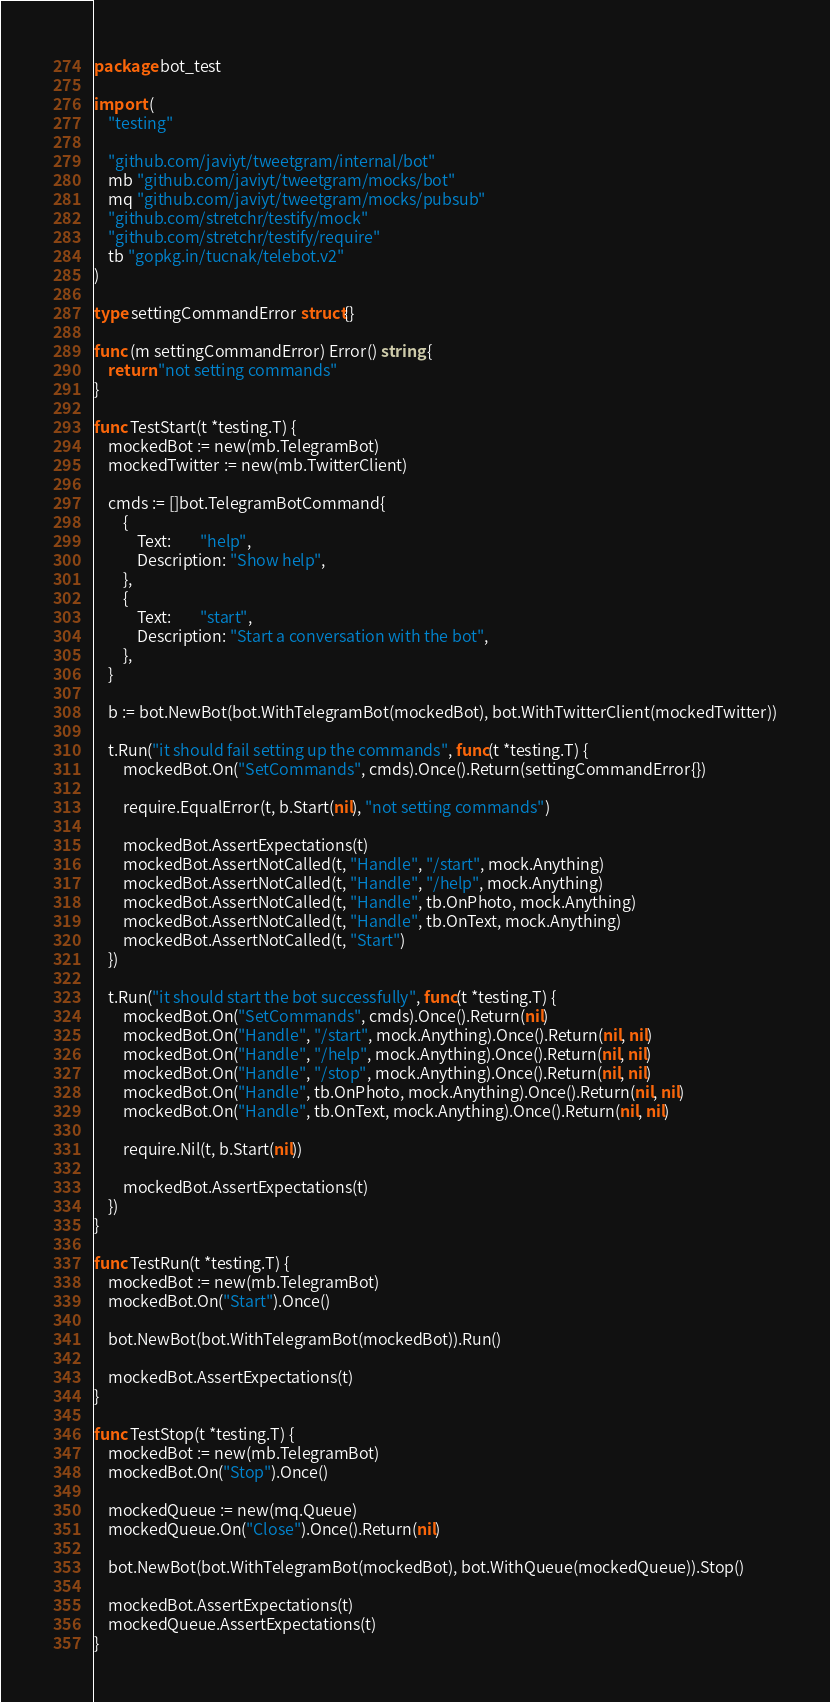<code> <loc_0><loc_0><loc_500><loc_500><_Go_>package bot_test

import (
	"testing"

	"github.com/javiyt/tweetgram/internal/bot"
	mb "github.com/javiyt/tweetgram/mocks/bot"
	mq "github.com/javiyt/tweetgram/mocks/pubsub"
	"github.com/stretchr/testify/mock"
	"github.com/stretchr/testify/require"
	tb "gopkg.in/tucnak/telebot.v2"
)

type settingCommandError struct{}

func (m settingCommandError) Error() string {
	return "not setting commands"
}

func TestStart(t *testing.T) {
	mockedBot := new(mb.TelegramBot)
	mockedTwitter := new(mb.TwitterClient)

	cmds := []bot.TelegramBotCommand{
		{
			Text:        "help",
			Description: "Show help",
		},
		{
			Text:        "start",
			Description: "Start a conversation with the bot",
		},
	}

	b := bot.NewBot(bot.WithTelegramBot(mockedBot), bot.WithTwitterClient(mockedTwitter))

	t.Run("it should fail setting up the commands", func(t *testing.T) {
		mockedBot.On("SetCommands", cmds).Once().Return(settingCommandError{})

		require.EqualError(t, b.Start(nil), "not setting commands")

		mockedBot.AssertExpectations(t)
		mockedBot.AssertNotCalled(t, "Handle", "/start", mock.Anything)
		mockedBot.AssertNotCalled(t, "Handle", "/help", mock.Anything)
		mockedBot.AssertNotCalled(t, "Handle", tb.OnPhoto, mock.Anything)
		mockedBot.AssertNotCalled(t, "Handle", tb.OnText, mock.Anything)
		mockedBot.AssertNotCalled(t, "Start")
	})

	t.Run("it should start the bot successfully", func(t *testing.T) {
		mockedBot.On("SetCommands", cmds).Once().Return(nil)
		mockedBot.On("Handle", "/start", mock.Anything).Once().Return(nil, nil)
		mockedBot.On("Handle", "/help", mock.Anything).Once().Return(nil, nil)
		mockedBot.On("Handle", "/stop", mock.Anything).Once().Return(nil, nil)
		mockedBot.On("Handle", tb.OnPhoto, mock.Anything).Once().Return(nil, nil)
		mockedBot.On("Handle", tb.OnText, mock.Anything).Once().Return(nil, nil)

		require.Nil(t, b.Start(nil))

		mockedBot.AssertExpectations(t)
	})
}

func TestRun(t *testing.T) {
	mockedBot := new(mb.TelegramBot)
	mockedBot.On("Start").Once()

	bot.NewBot(bot.WithTelegramBot(mockedBot)).Run()

	mockedBot.AssertExpectations(t)
}

func TestStop(t *testing.T) {
	mockedBot := new(mb.TelegramBot)
	mockedBot.On("Stop").Once()

	mockedQueue := new(mq.Queue)
	mockedQueue.On("Close").Once().Return(nil)

	bot.NewBot(bot.WithTelegramBot(mockedBot), bot.WithQueue(mockedQueue)).Stop()

	mockedBot.AssertExpectations(t)
	mockedQueue.AssertExpectations(t)
}
</code> 